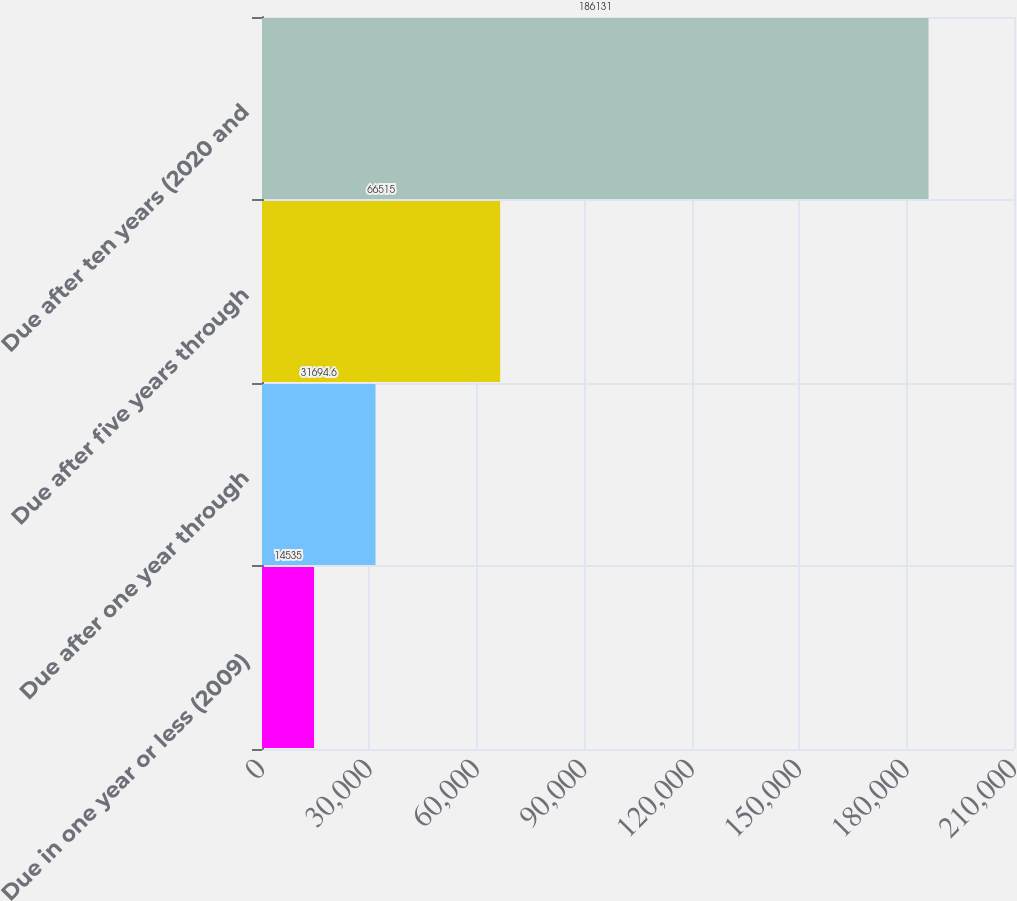<chart> <loc_0><loc_0><loc_500><loc_500><bar_chart><fcel>Due in one year or less (2009)<fcel>Due after one year through<fcel>Due after five years through<fcel>Due after ten years (2020 and<nl><fcel>14535<fcel>31694.6<fcel>66515<fcel>186131<nl></chart> 